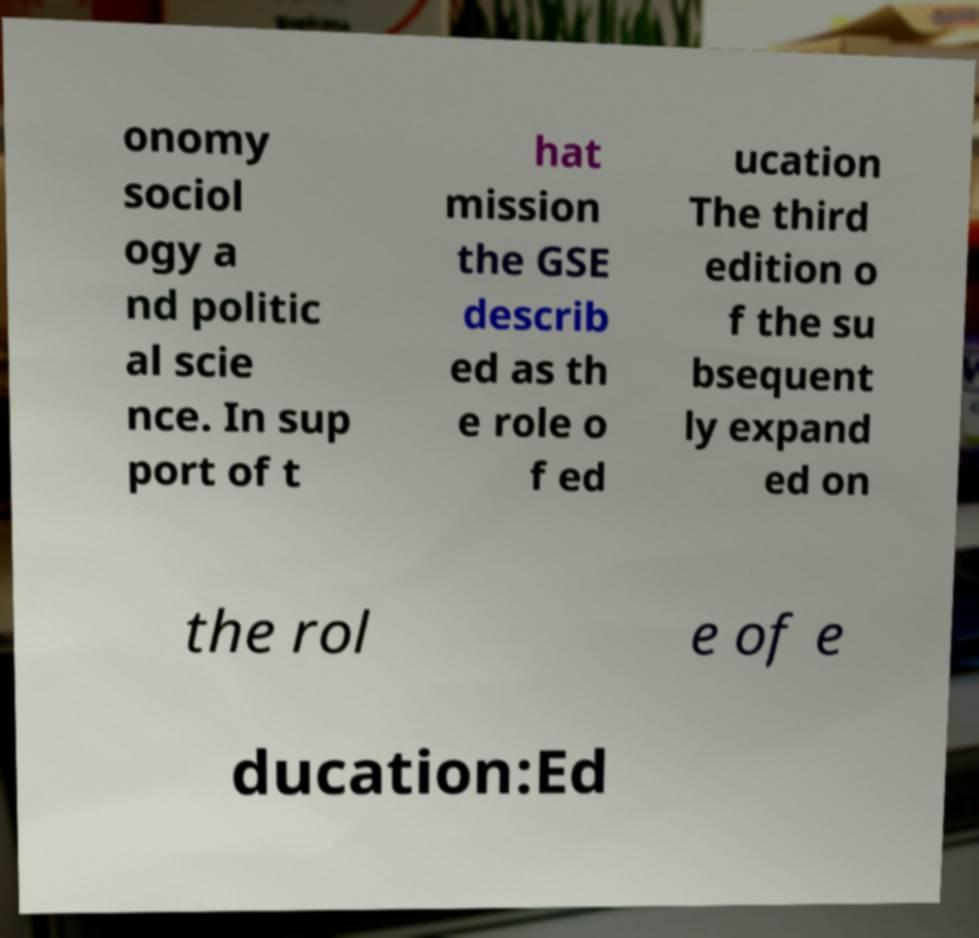What messages or text are displayed in this image? I need them in a readable, typed format. onomy sociol ogy a nd politic al scie nce. In sup port of t hat mission the GSE describ ed as th e role o f ed ucation The third edition o f the su bsequent ly expand ed on the rol e of e ducation:Ed 